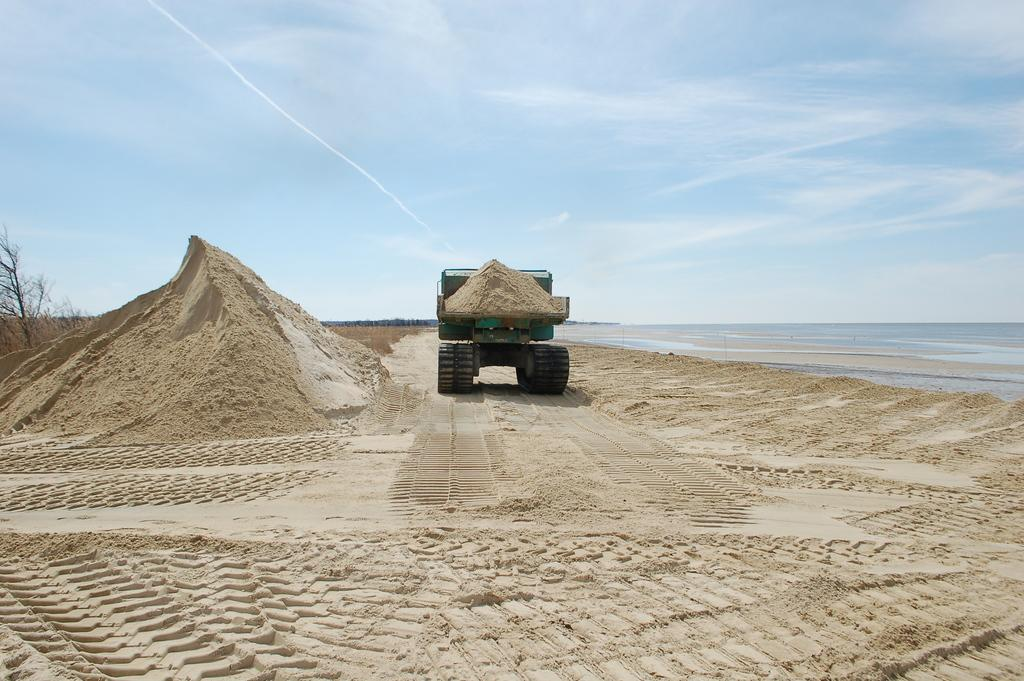What type of terrain is depicted in the image? There is sand in the image, suggesting a desert or beach setting. What natural element can be seen in the image? There is a dry tree in the image. What man-made object is present in the image? There is a vehicle in the image. What is visible at the top of the image? The sky is visible at the top of the image. How does the beginner learn to escape from the prison in the image? There is no prison or beginner present in the image; it features sand, a dry tree, a vehicle, and the sky. 